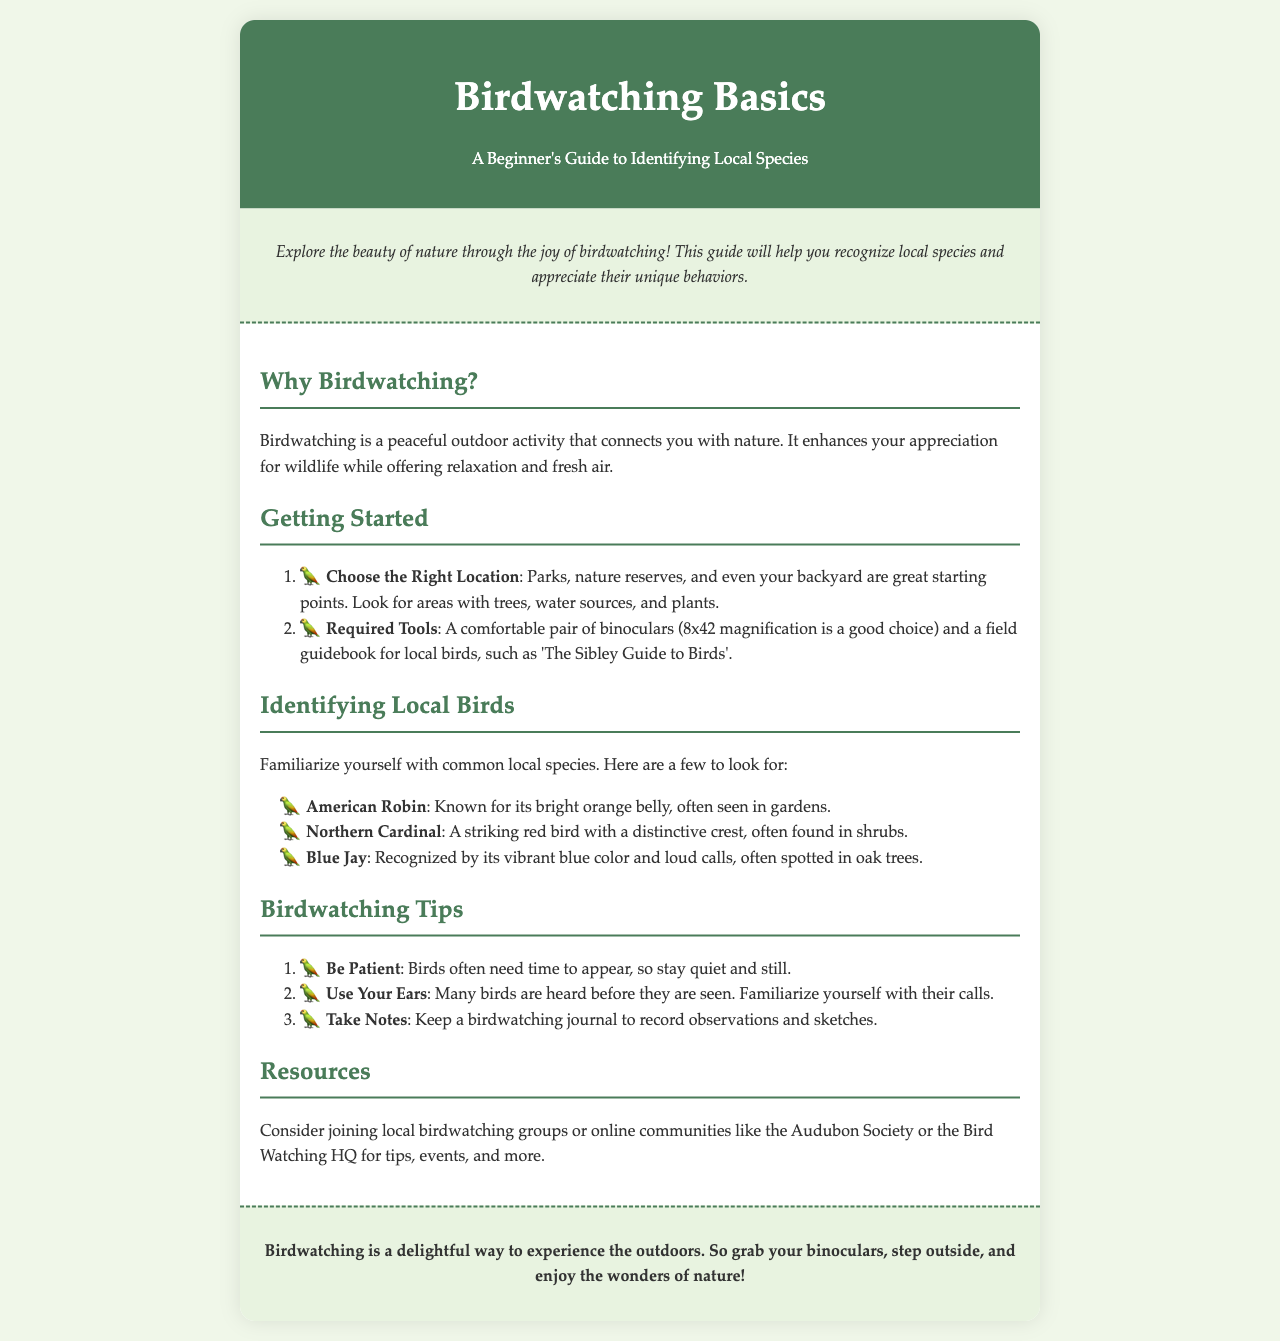What is the title of the guide? The title of the guide is provided in the header section of the document.
Answer: Birdwatching Basics What is one tool recommended for birdwatching? The document mentions specific tools required for birdwatching in the 'Required Tools' section.
Answer: Binoculars Name a bird that is identified as common in the guide. The guide lists common birds in the 'Identifying Local Birds' section.
Answer: American Robin What color is the Northern Cardinal? The description of the Northern Cardinal in the document specifies its color.
Answer: Red How many tips for birdwatching are provided? The document lists birdwatching tips in a numbered list; the total is counted from this list.
Answer: Three Why is birdwatching considered a peaceful activity? The document explains the benefits of birdwatching in the 'Why Birdwatching?' section.
Answer: It connects you with nature What type of locations are best for starting birdwatching? The guide suggests types of locations in the 'Choose the Right Location' section.
Answer: Parks What is a good example of a field guidebook for local birds? The document recommends a specific book as a resource in the 'Required Tools' section.
Answer: The Sibley Guide to Birds Which organization is mentioned for joining local birdwatching groups? The document mentions specific organizations in the 'Resources' section for community involvement.
Answer: Audubon Society 